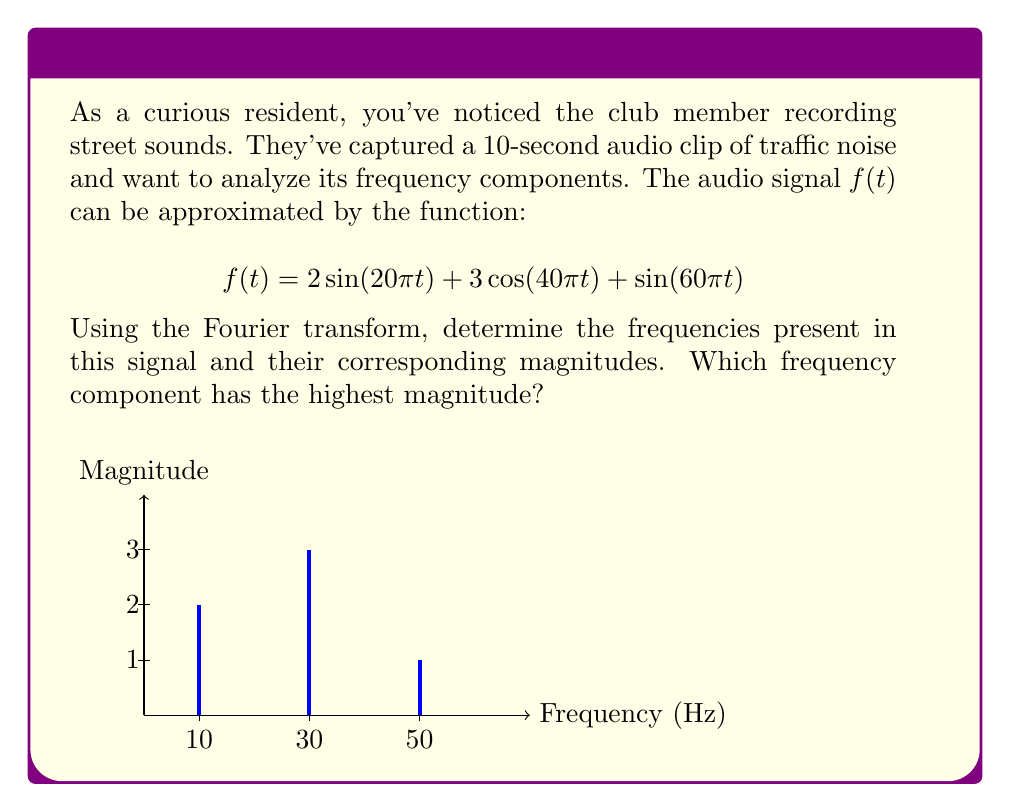Provide a solution to this math problem. To analyze the frequency components using the Fourier transform, we need to follow these steps:

1) Identify the sinusoidal components in the given function:
   $$f(t) = 2\sin(20\pi t) + 3\cos(40\pi t) + \sin(60\pi t)$$

2) For each component, determine the frequency and magnitude:

   a) $2\sin(20\pi t)$:
      Frequency: $\frac{20\pi}{2\pi} = 10$ Hz
      Magnitude: 2

   b) $3\cos(40\pi t)$:
      Frequency: $\frac{40\pi}{2\pi} = 20$ Hz
      Magnitude: 3

   c) $\sin(60\pi t)$:
      Frequency: $\frac{60\pi}{2\pi} = 30$ Hz
      Magnitude: 1

3) The Fourier transform will show these frequency components as spikes at their respective frequencies, with heights corresponding to their magnitudes.

4) To determine which frequency component has the highest magnitude, we compare the magnitudes:
   2 (10 Hz), 3 (20 Hz), and 1 (30 Hz)

The highest magnitude is 3, corresponding to the 20 Hz component.
Answer: 20 Hz component with magnitude 3 